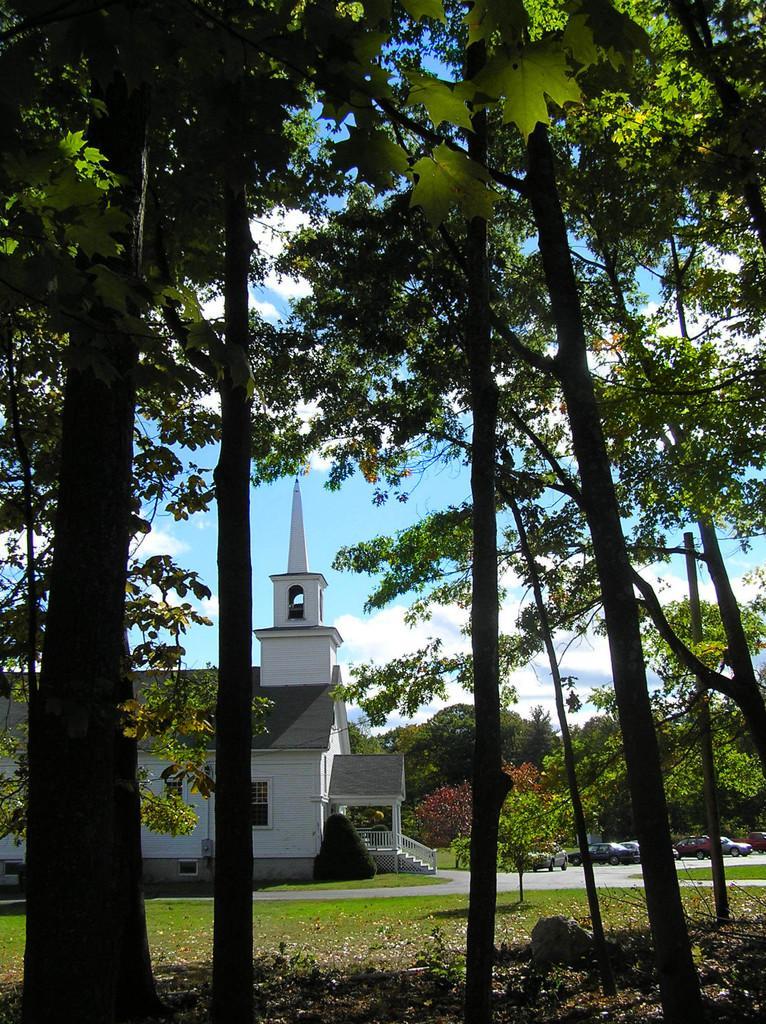How would you summarize this image in a sentence or two? In this picture we can see trees, grass, rock, vehicles on the road and house. In the background of the image we can see the sky. 